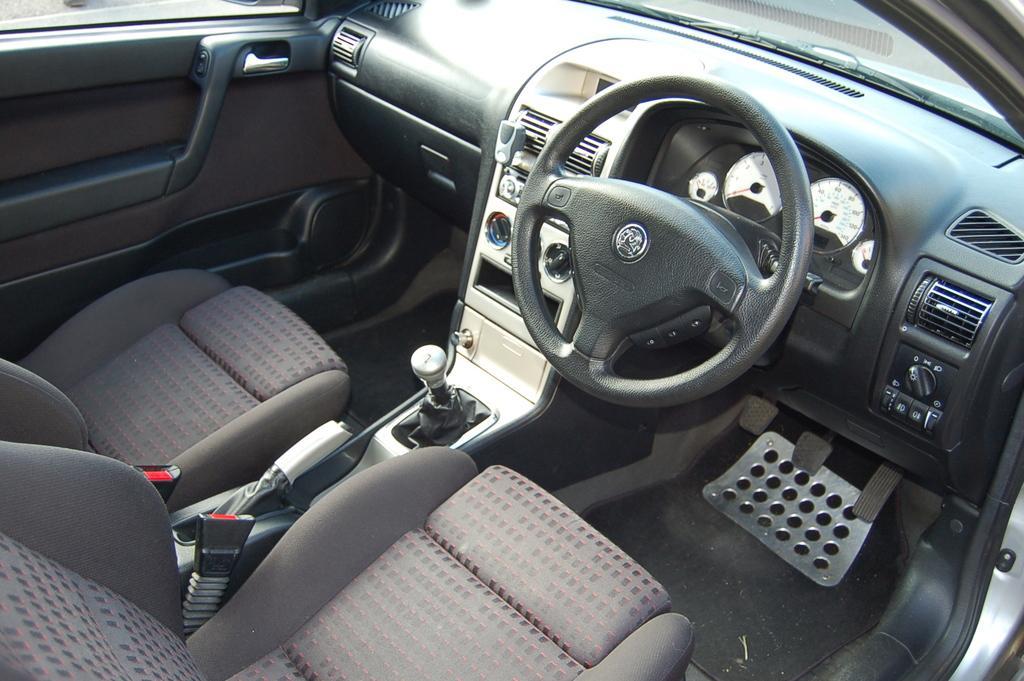How would you summarize this image in a sentence or two? This is the interior picture of car with windshield, steering wheel, seats, clutch, brake, gear lever, air vent and door handles. 